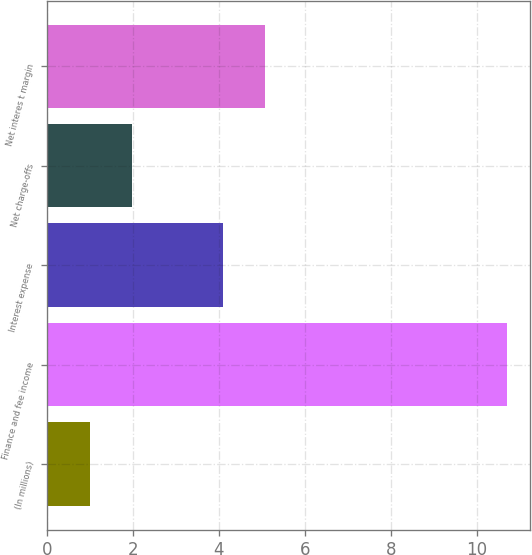Convert chart. <chart><loc_0><loc_0><loc_500><loc_500><bar_chart><fcel>(In millions)<fcel>Finance and fee income<fcel>Interest expense<fcel>Net charge-offs<fcel>Net interes t margin<nl><fcel>1<fcel>10.7<fcel>4.1<fcel>1.97<fcel>5.07<nl></chart> 